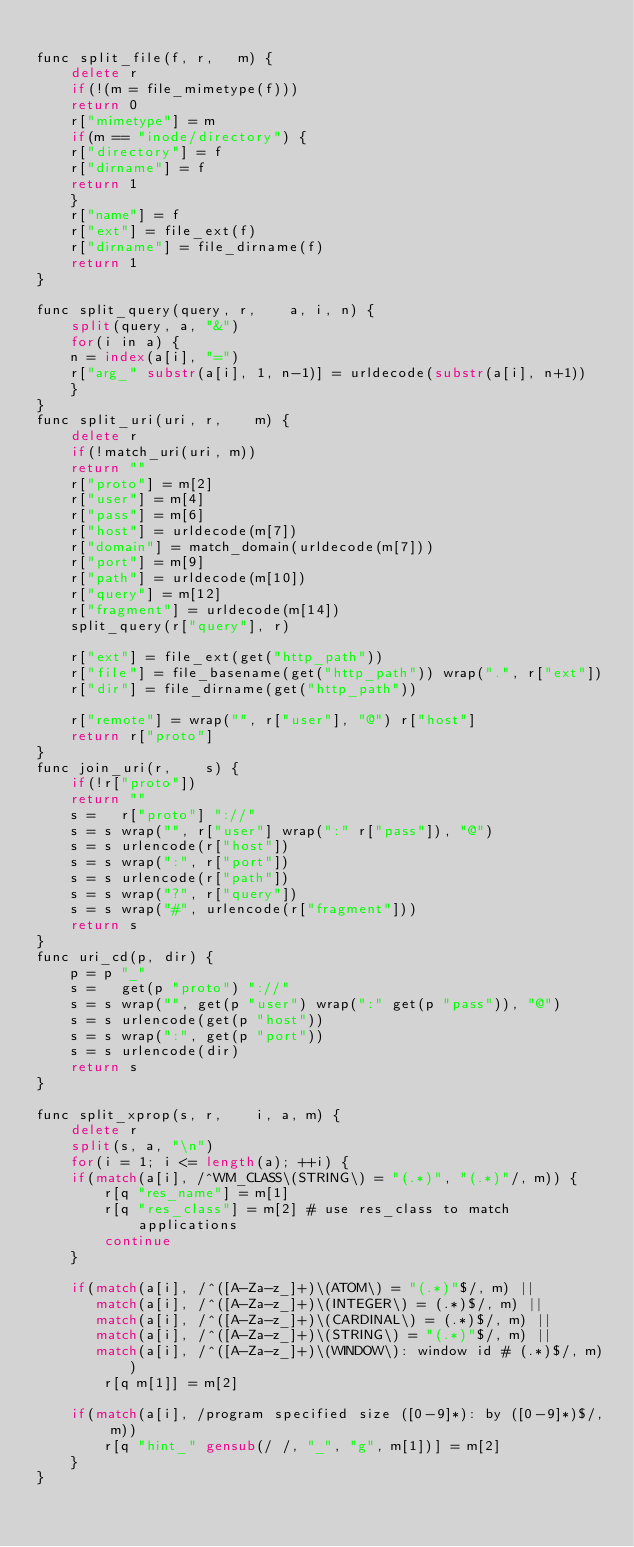<code> <loc_0><loc_0><loc_500><loc_500><_Awk_>
func split_file(f, r,   m) {
    delete r
    if(!(m = file_mimetype(f)))
	return 0
    r["mimetype"] = m
    if(m == "inode/directory") {
	r["directory"] = f
	r["dirname"] = f
	return 1
    }
    r["name"] = f
    r["ext"] = file_ext(f)
    r["dirname"] = file_dirname(f)
    return 1
}

func split_query(query, r,    a, i, n) {
    split(query, a, "&")
    for(i in a) {
	n = index(a[i], "=")
	r["arg_" substr(a[i], 1, n-1)] = urldecode(substr(a[i], n+1))
    }
}
func split_uri(uri, r,    m) {
    delete r
    if(!match_uri(uri, m))
	return ""
    r["proto"] = m[2]
    r["user"] = m[4]
    r["pass"] = m[6]
    r["host"] = urldecode(m[7])
    r["domain"] = match_domain(urldecode(m[7]))
    r["port"] = m[9]
    r["path"] = urldecode(m[10])
    r["query"] = m[12]
    r["fragment"] = urldecode(m[14])
    split_query(r["query"], r)

    r["ext"] = file_ext(get("http_path"))
    r["file"] = file_basename(get("http_path")) wrap(".", r["ext"])
    r["dir"] = file_dirname(get("http_path"))

    r["remote"] = wrap("", r["user"], "@") r["host"]
    return r["proto"]
}
func join_uri(r,    s) {
    if(!r["proto"])
	return ""
    s =   r["proto"] "://" 
    s = s wrap("", r["user"] wrap(":" r["pass"]), "@")
    s = s urlencode(r["host"])
    s = s wrap(":", r["port"])
    s = s urlencode(r["path"])
    s = s wrap("?", r["query"])
    s = s wrap("#", urlencode(r["fragment"]))
    return s
}
func uri_cd(p, dir) {
    p = p "_"
    s =   get(p "proto") "://" 
    s = s wrap("", get(p "user") wrap(":" get(p "pass")), "@")
    s = s urlencode(get(p "host"))
    s = s wrap(":", get(p "port"))
    s = s urlencode(dir)
    return s
}

func split_xprop(s, r,    i, a, m) {
    delete r
    split(s, a, "\n")
    for(i = 1; i <= length(a); ++i) {
	if(match(a[i], /^WM_CLASS\(STRING\) = "(.*)", "(.*)"/, m)) {
	    r[q "res_name"] = m[1]
	    r[q "res_class"] = m[2] # use res_class to match applications
	    continue
	}

	if(match(a[i], /^([A-Za-z_]+)\(ATOM\) = "(.*)"$/, m) ||
	   match(a[i], /^([A-Za-z_]+)\(INTEGER\) = (.*)$/, m) ||
	   match(a[i], /^([A-Za-z_]+)\(CARDINAL\) = (.*)$/, m) ||
	   match(a[i], /^([A-Za-z_]+)\(STRING\) = "(.*)"$/, m) ||
	   match(a[i], /^([A-Za-z_]+)\(WINDOW\): window id # (.*)$/, m))
	    r[q m[1]] = m[2]

	if(match(a[i], /program specified size ([0-9]*): by ([0-9]*)$/, m))
	    r[q "hint_" gensub(/ /, "_", "g", m[1])] = m[2]
    }
}
</code> 